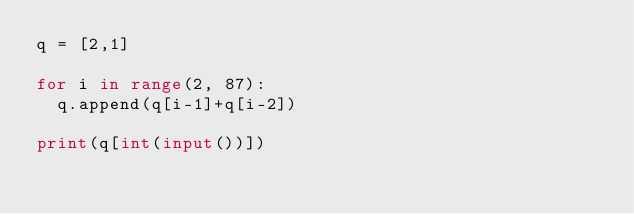Convert code to text. <code><loc_0><loc_0><loc_500><loc_500><_Python_>q = [2,1]

for i in range(2, 87):
	q.append(q[i-1]+q[i-2])
	
print(q[int(input())])</code> 